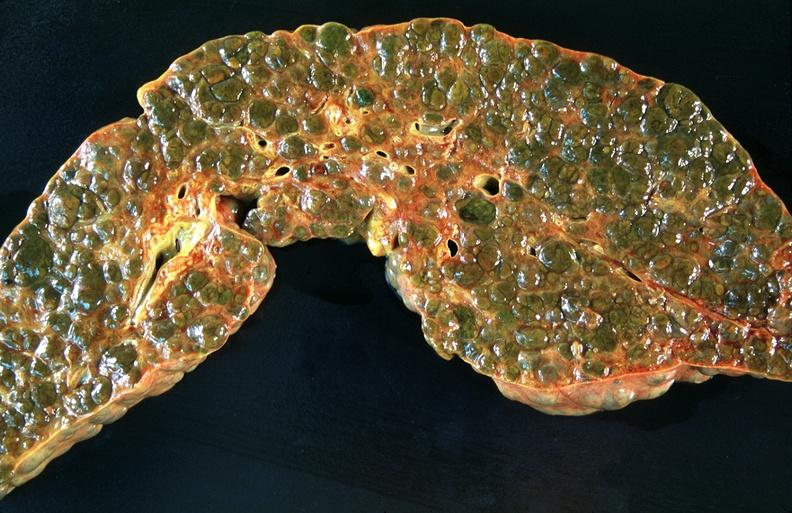what does this image show?
Answer the question using a single word or phrase. Liver 